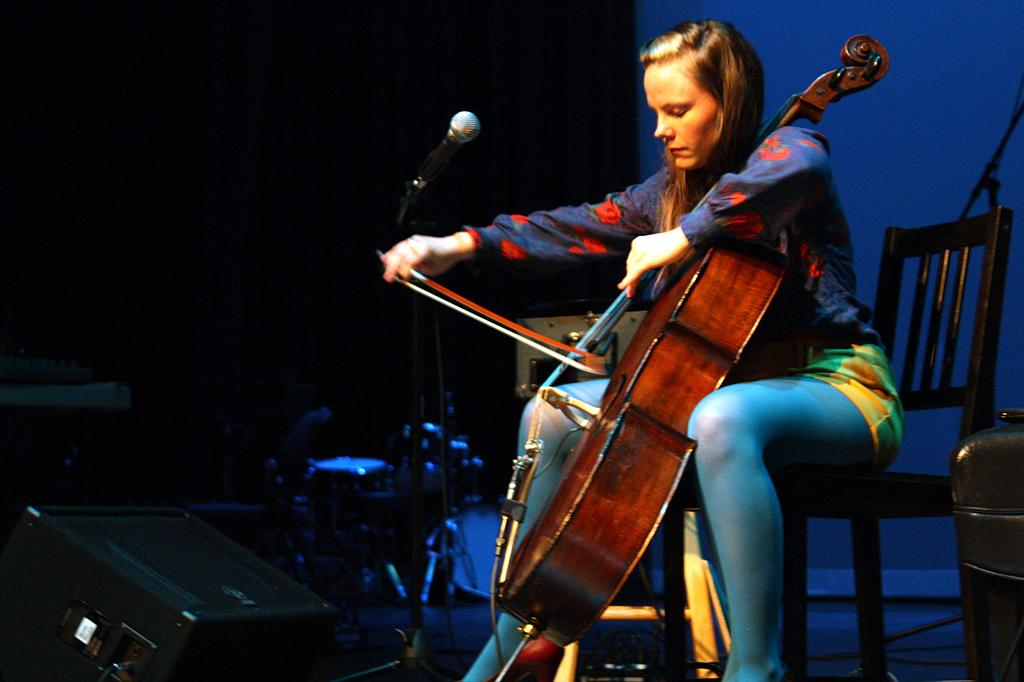Who is the main subject in the image? There is a woman in the image. What is the woman doing in the image? The woman is playing a violin. What object is the woman using to amplify her sound? The woman is in front of a microphone. What is the woman sitting on in the image? The woman is sitting on a chair. Can you hear the robin singing in the background of the image? There is no robin or any sound mentioned in the image, so it is not possible to determine if a robin is singing in the background. 